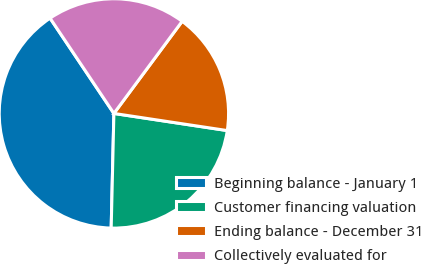Convert chart to OTSL. <chart><loc_0><loc_0><loc_500><loc_500><pie_chart><fcel>Beginning balance - January 1<fcel>Customer financing valuation<fcel>Ending balance - December 31<fcel>Collectively evaluated for<nl><fcel>40.23%<fcel>22.99%<fcel>17.24%<fcel>19.54%<nl></chart> 